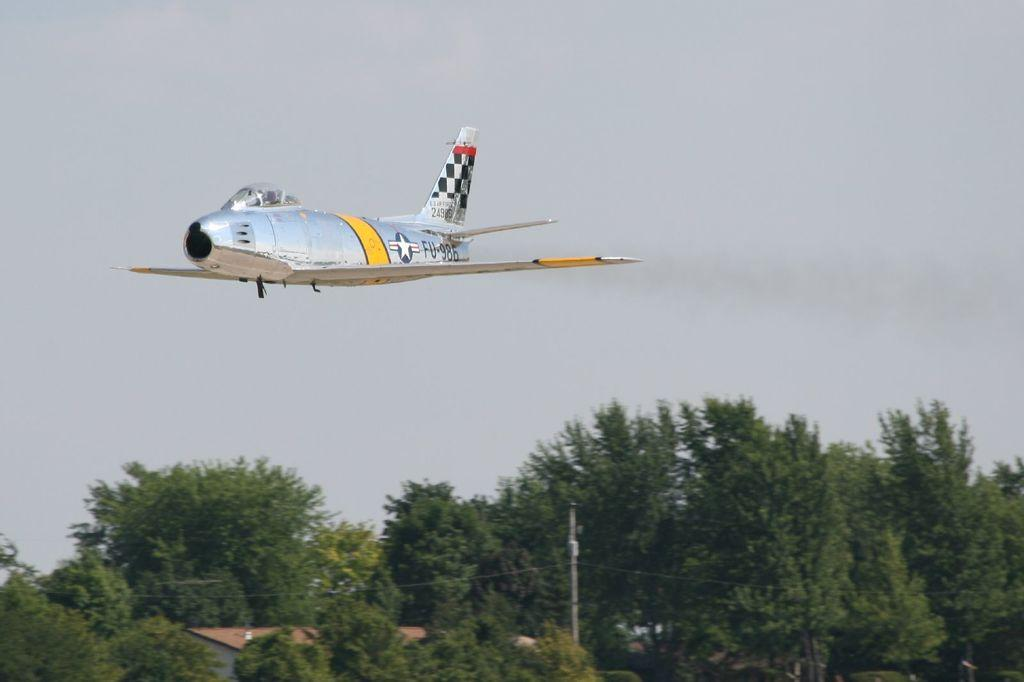What type of vegetation can be seen in the image? There are trees in the image. What is the main subject in the middle of the image? There is a jet in the middle of the image. What object can be seen standing upright in the image? There is a pole in the image. What type of structure is visible at the bottom of the image? There is a roof house at the bottom of the image. What is visible at the top of the image? The sky is visible at the top of the image. What type of beef is being cooked on the pole in the image? There is no beef or cooking activity present in the image; it features a jet, trees, a pole, a roof house, and the sky. What color is the ink used to write on the roof house in the image? There is no ink or writing present on the roof house in the image. 